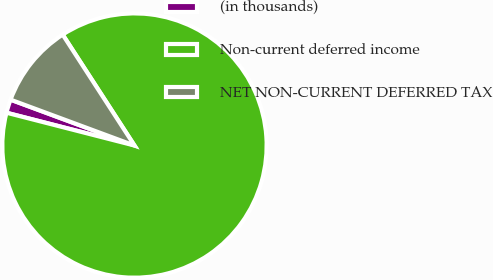<chart> <loc_0><loc_0><loc_500><loc_500><pie_chart><fcel>(in thousands)<fcel>Non-current deferred income<fcel>NET NON-CURRENT DEFERRED TAX<nl><fcel>1.65%<fcel>88.14%<fcel>10.21%<nl></chart> 